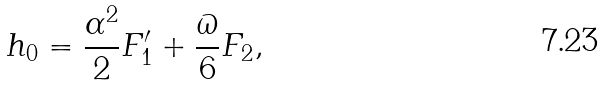Convert formula to latex. <formula><loc_0><loc_0><loc_500><loc_500>h _ { 0 } = \frac { \alpha ^ { 2 } } { 2 } F _ { 1 } ^ { \prime } + \frac { \varpi } { 6 } F _ { 2 } ,</formula> 